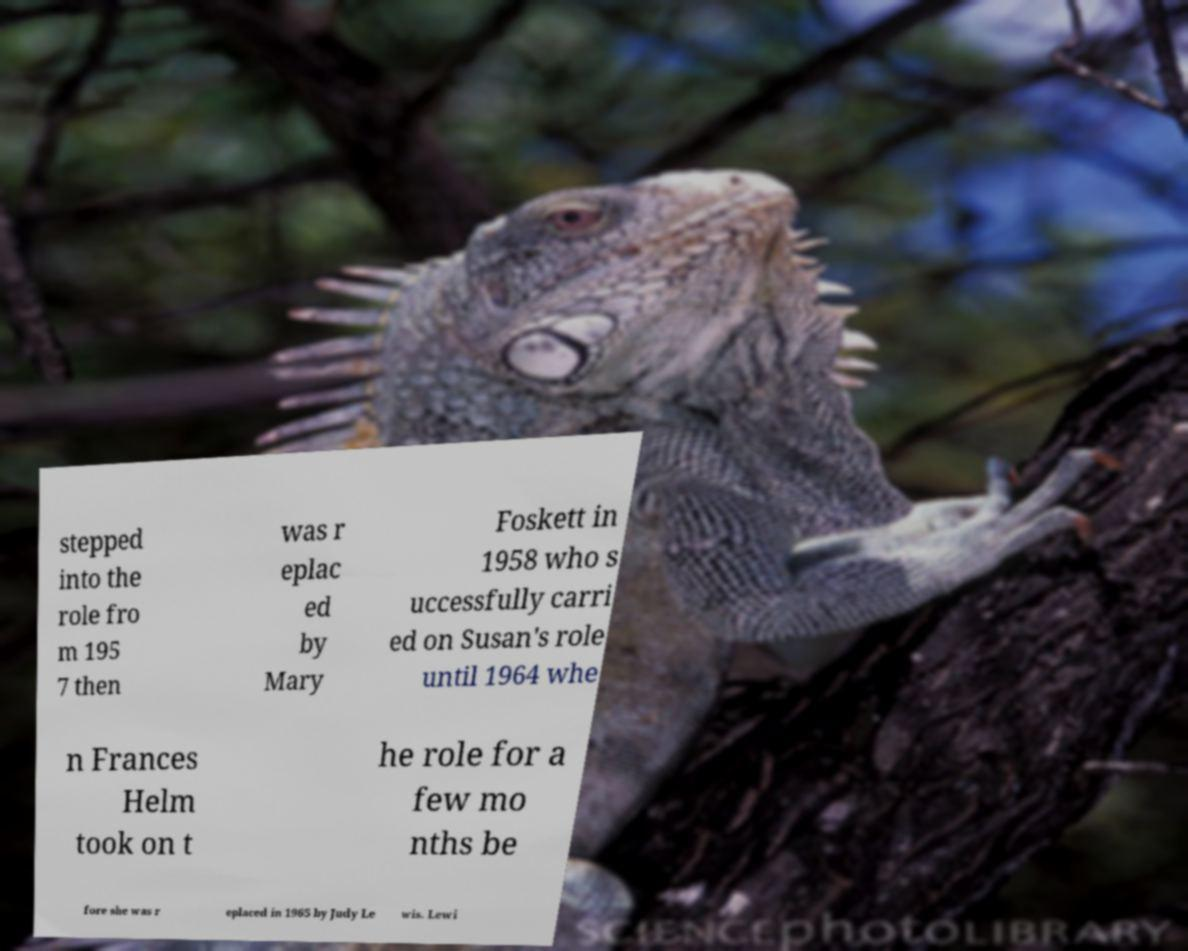Could you assist in decoding the text presented in this image and type it out clearly? stepped into the role fro m 195 7 then was r eplac ed by Mary Foskett in 1958 who s uccessfully carri ed on Susan's role until 1964 whe n Frances Helm took on t he role for a few mo nths be fore she was r eplaced in 1965 by Judy Le wis. Lewi 